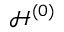Convert formula to latex. <formula><loc_0><loc_0><loc_500><loc_500>\mathcal { H } ^ { \left ( 0 \right ) }</formula> 